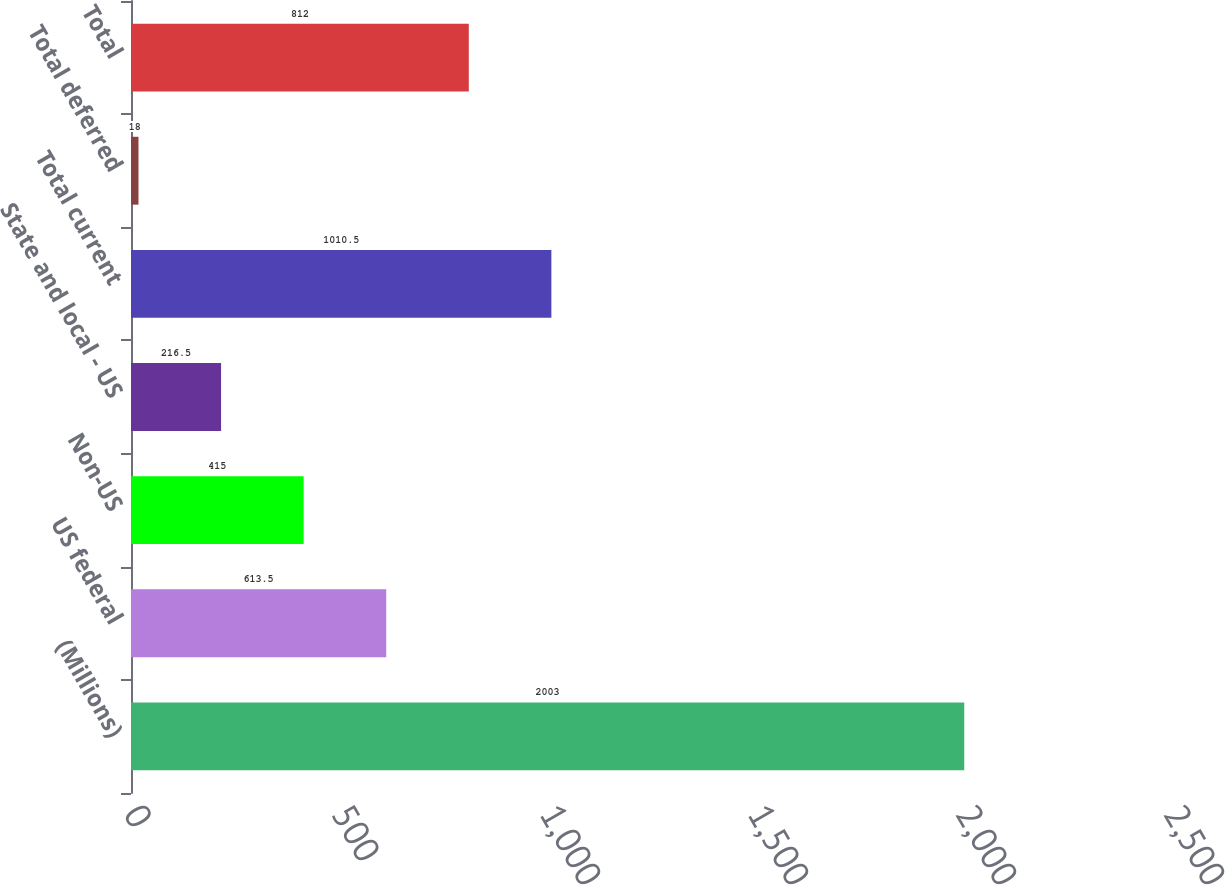<chart> <loc_0><loc_0><loc_500><loc_500><bar_chart><fcel>(Millions)<fcel>US federal<fcel>Non-US<fcel>State and local - US<fcel>Total current<fcel>Total deferred<fcel>Total<nl><fcel>2003<fcel>613.5<fcel>415<fcel>216.5<fcel>1010.5<fcel>18<fcel>812<nl></chart> 